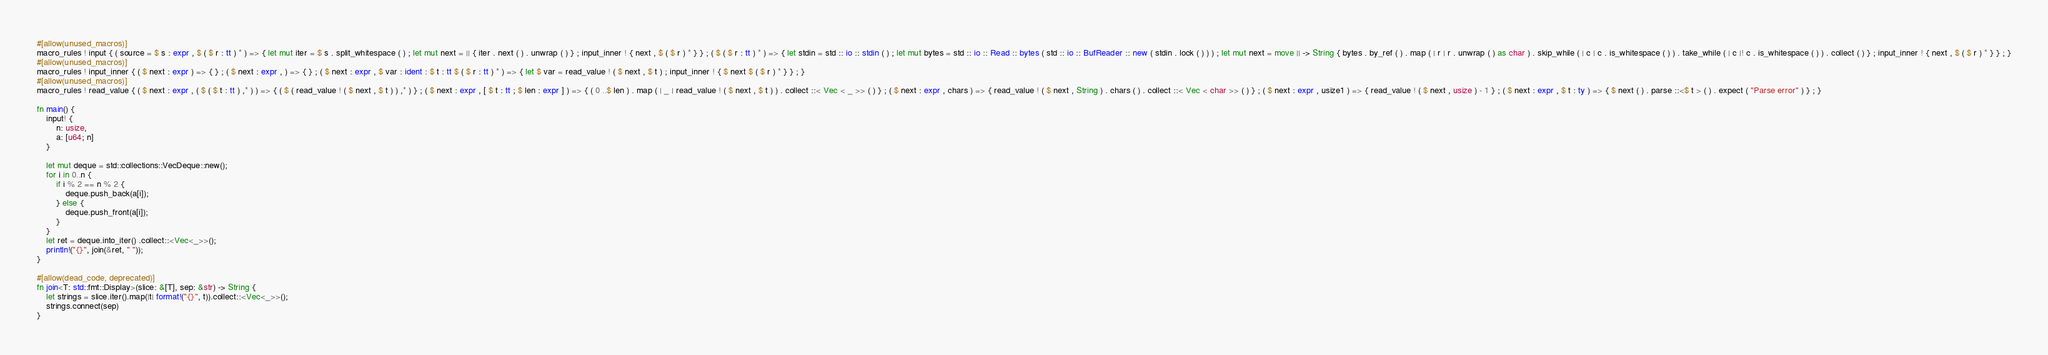<code> <loc_0><loc_0><loc_500><loc_500><_Rust_>#[allow(unused_macros)]
macro_rules ! input { ( source = $ s : expr , $ ( $ r : tt ) * ) => { let mut iter = $ s . split_whitespace ( ) ; let mut next = || { iter . next ( ) . unwrap ( ) } ; input_inner ! { next , $ ( $ r ) * } } ; ( $ ( $ r : tt ) * ) => { let stdin = std :: io :: stdin ( ) ; let mut bytes = std :: io :: Read :: bytes ( std :: io :: BufReader :: new ( stdin . lock ( ) ) ) ; let mut next = move || -> String { bytes . by_ref ( ) . map ( | r | r . unwrap ( ) as char ) . skip_while ( | c | c . is_whitespace ( ) ) . take_while ( | c |! c . is_whitespace ( ) ) . collect ( ) } ; input_inner ! { next , $ ( $ r ) * } } ; }
#[allow(unused_macros)]
macro_rules ! input_inner { ( $ next : expr ) => { } ; ( $ next : expr , ) => { } ; ( $ next : expr , $ var : ident : $ t : tt $ ( $ r : tt ) * ) => { let $ var = read_value ! ( $ next , $ t ) ; input_inner ! { $ next $ ( $ r ) * } } ; }
#[allow(unused_macros)]
macro_rules ! read_value { ( $ next : expr , ( $ ( $ t : tt ) ,* ) ) => { ( $ ( read_value ! ( $ next , $ t ) ) ,* ) } ; ( $ next : expr , [ $ t : tt ; $ len : expr ] ) => { ( 0 ..$ len ) . map ( | _ | read_value ! ( $ next , $ t ) ) . collect ::< Vec < _ >> ( ) } ; ( $ next : expr , chars ) => { read_value ! ( $ next , String ) . chars ( ) . collect ::< Vec < char >> ( ) } ; ( $ next : expr , usize1 ) => { read_value ! ( $ next , usize ) - 1 } ; ( $ next : expr , $ t : ty ) => { $ next ( ) . parse ::<$ t > ( ) . expect ( "Parse error" ) } ; }

fn main() {
    input! {
        n: usize,
        a: [u64; n]
    }

    let mut deque = std::collections::VecDeque::new();
    for i in 0..n {
        if i % 2 == n % 2 {
            deque.push_back(a[i]);
        } else {
            deque.push_front(a[i]);
        }
    }
    let ret = deque.into_iter() .collect::<Vec<_>>();
    println!("{}", join(&ret, " "));
}

#[allow(dead_code, deprecated)]
fn join<T: std::fmt::Display>(slice: &[T], sep: &str) -> String {
    let strings = slice.iter().map(|t| format!("{}", t)).collect::<Vec<_>>();
    strings.connect(sep)
}</code> 